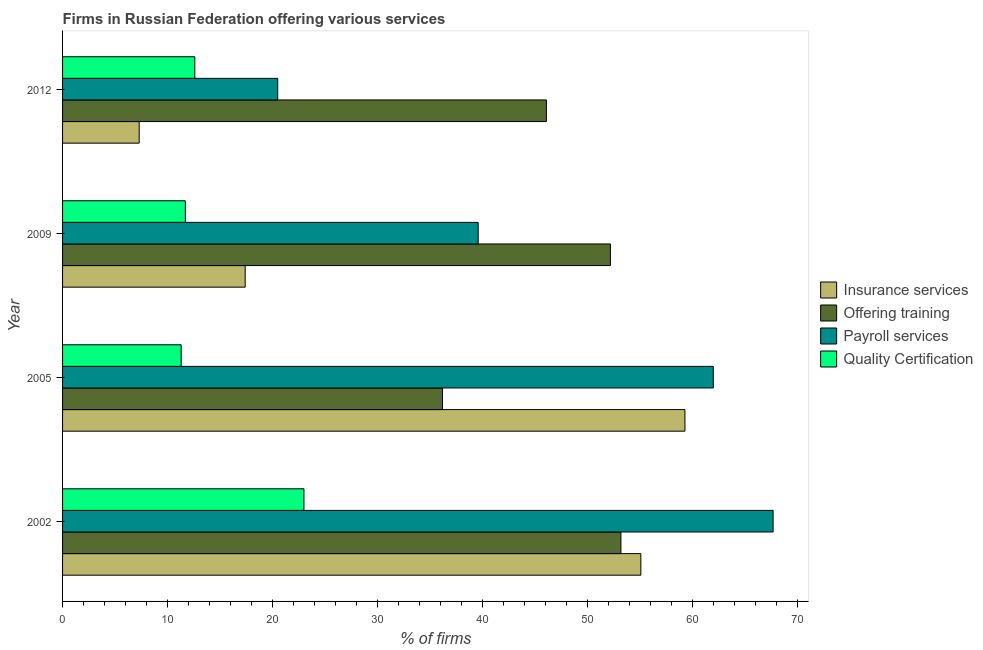How many different coloured bars are there?
Provide a short and direct response. 4. How many groups of bars are there?
Offer a terse response. 4. Are the number of bars per tick equal to the number of legend labels?
Your answer should be compact. Yes. How many bars are there on the 4th tick from the top?
Keep it short and to the point. 4. How many bars are there on the 2nd tick from the bottom?
Provide a short and direct response. 4. In how many cases, is the number of bars for a given year not equal to the number of legend labels?
Offer a terse response. 0. What is the percentage of firms offering insurance services in 2005?
Provide a short and direct response. 59.3. Across all years, what is the maximum percentage of firms offering quality certification?
Provide a succinct answer. 23. Across all years, what is the minimum percentage of firms offering quality certification?
Keep it short and to the point. 11.3. In which year was the percentage of firms offering quality certification maximum?
Provide a succinct answer. 2002. In which year was the percentage of firms offering insurance services minimum?
Provide a succinct answer. 2012. What is the total percentage of firms offering payroll services in the graph?
Your answer should be very brief. 189.8. What is the difference between the percentage of firms offering payroll services in 2002 and the percentage of firms offering training in 2009?
Provide a succinct answer. 15.5. What is the average percentage of firms offering insurance services per year?
Offer a very short reply. 34.77. In the year 2012, what is the difference between the percentage of firms offering payroll services and percentage of firms offering insurance services?
Keep it short and to the point. 13.2. In how many years, is the percentage of firms offering training greater than 26 %?
Your response must be concise. 4. What is the ratio of the percentage of firms offering insurance services in 2002 to that in 2009?
Your answer should be very brief. 3.17. Is the difference between the percentage of firms offering training in 2005 and 2009 greater than the difference between the percentage of firms offering quality certification in 2005 and 2009?
Your response must be concise. No. What is the difference between the highest and the second highest percentage of firms offering quality certification?
Keep it short and to the point. 10.4. What is the difference between the highest and the lowest percentage of firms offering training?
Your answer should be very brief. 17. In how many years, is the percentage of firms offering training greater than the average percentage of firms offering training taken over all years?
Your answer should be very brief. 2. Is the sum of the percentage of firms offering insurance services in 2002 and 2009 greater than the maximum percentage of firms offering quality certification across all years?
Offer a terse response. Yes. What does the 3rd bar from the top in 2002 represents?
Keep it short and to the point. Offering training. What does the 4th bar from the bottom in 2002 represents?
Your answer should be very brief. Quality Certification. Is it the case that in every year, the sum of the percentage of firms offering insurance services and percentage of firms offering training is greater than the percentage of firms offering payroll services?
Keep it short and to the point. Yes. How many years are there in the graph?
Your answer should be very brief. 4. Does the graph contain grids?
Ensure brevity in your answer.  No. Where does the legend appear in the graph?
Make the answer very short. Center right. What is the title of the graph?
Make the answer very short. Firms in Russian Federation offering various services . What is the label or title of the X-axis?
Provide a succinct answer. % of firms. What is the % of firms of Insurance services in 2002?
Provide a succinct answer. 55.1. What is the % of firms in Offering training in 2002?
Give a very brief answer. 53.2. What is the % of firms of Payroll services in 2002?
Your answer should be compact. 67.7. What is the % of firms of Insurance services in 2005?
Keep it short and to the point. 59.3. What is the % of firms in Offering training in 2005?
Provide a succinct answer. 36.2. What is the % of firms of Payroll services in 2005?
Provide a succinct answer. 62. What is the % of firms in Quality Certification in 2005?
Offer a very short reply. 11.3. What is the % of firms in Insurance services in 2009?
Your response must be concise. 17.4. What is the % of firms of Offering training in 2009?
Your response must be concise. 52.2. What is the % of firms in Payroll services in 2009?
Offer a very short reply. 39.6. What is the % of firms in Quality Certification in 2009?
Your response must be concise. 11.7. What is the % of firms in Offering training in 2012?
Your response must be concise. 46.1. What is the % of firms of Payroll services in 2012?
Offer a very short reply. 20.5. What is the % of firms in Quality Certification in 2012?
Your answer should be very brief. 12.6. Across all years, what is the maximum % of firms of Insurance services?
Keep it short and to the point. 59.3. Across all years, what is the maximum % of firms of Offering training?
Your response must be concise. 53.2. Across all years, what is the maximum % of firms of Payroll services?
Ensure brevity in your answer.  67.7. Across all years, what is the maximum % of firms of Quality Certification?
Offer a terse response. 23. Across all years, what is the minimum % of firms of Insurance services?
Make the answer very short. 7.3. Across all years, what is the minimum % of firms of Offering training?
Offer a terse response. 36.2. What is the total % of firms of Insurance services in the graph?
Your answer should be compact. 139.1. What is the total % of firms of Offering training in the graph?
Keep it short and to the point. 187.7. What is the total % of firms of Payroll services in the graph?
Keep it short and to the point. 189.8. What is the total % of firms in Quality Certification in the graph?
Keep it short and to the point. 58.6. What is the difference between the % of firms in Payroll services in 2002 and that in 2005?
Provide a short and direct response. 5.7. What is the difference between the % of firms of Insurance services in 2002 and that in 2009?
Give a very brief answer. 37.7. What is the difference between the % of firms of Payroll services in 2002 and that in 2009?
Keep it short and to the point. 28.1. What is the difference between the % of firms in Insurance services in 2002 and that in 2012?
Your answer should be compact. 47.8. What is the difference between the % of firms of Payroll services in 2002 and that in 2012?
Your answer should be compact. 47.2. What is the difference between the % of firms in Insurance services in 2005 and that in 2009?
Keep it short and to the point. 41.9. What is the difference between the % of firms of Payroll services in 2005 and that in 2009?
Offer a terse response. 22.4. What is the difference between the % of firms of Quality Certification in 2005 and that in 2009?
Your response must be concise. -0.4. What is the difference between the % of firms in Insurance services in 2005 and that in 2012?
Give a very brief answer. 52. What is the difference between the % of firms in Payroll services in 2005 and that in 2012?
Provide a succinct answer. 41.5. What is the difference between the % of firms of Quality Certification in 2005 and that in 2012?
Give a very brief answer. -1.3. What is the difference between the % of firms in Payroll services in 2009 and that in 2012?
Keep it short and to the point. 19.1. What is the difference between the % of firms in Insurance services in 2002 and the % of firms in Offering training in 2005?
Make the answer very short. 18.9. What is the difference between the % of firms of Insurance services in 2002 and the % of firms of Payroll services in 2005?
Provide a succinct answer. -6.9. What is the difference between the % of firms in Insurance services in 2002 and the % of firms in Quality Certification in 2005?
Make the answer very short. 43.8. What is the difference between the % of firms of Offering training in 2002 and the % of firms of Payroll services in 2005?
Provide a succinct answer. -8.8. What is the difference between the % of firms of Offering training in 2002 and the % of firms of Quality Certification in 2005?
Provide a short and direct response. 41.9. What is the difference between the % of firms in Payroll services in 2002 and the % of firms in Quality Certification in 2005?
Make the answer very short. 56.4. What is the difference between the % of firms in Insurance services in 2002 and the % of firms in Payroll services in 2009?
Provide a short and direct response. 15.5. What is the difference between the % of firms in Insurance services in 2002 and the % of firms in Quality Certification in 2009?
Your answer should be compact. 43.4. What is the difference between the % of firms in Offering training in 2002 and the % of firms in Payroll services in 2009?
Your response must be concise. 13.6. What is the difference between the % of firms of Offering training in 2002 and the % of firms of Quality Certification in 2009?
Offer a very short reply. 41.5. What is the difference between the % of firms in Payroll services in 2002 and the % of firms in Quality Certification in 2009?
Provide a succinct answer. 56. What is the difference between the % of firms in Insurance services in 2002 and the % of firms in Offering training in 2012?
Ensure brevity in your answer.  9. What is the difference between the % of firms in Insurance services in 2002 and the % of firms in Payroll services in 2012?
Make the answer very short. 34.6. What is the difference between the % of firms in Insurance services in 2002 and the % of firms in Quality Certification in 2012?
Provide a succinct answer. 42.5. What is the difference between the % of firms in Offering training in 2002 and the % of firms in Payroll services in 2012?
Offer a very short reply. 32.7. What is the difference between the % of firms of Offering training in 2002 and the % of firms of Quality Certification in 2012?
Make the answer very short. 40.6. What is the difference between the % of firms of Payroll services in 2002 and the % of firms of Quality Certification in 2012?
Give a very brief answer. 55.1. What is the difference between the % of firms in Insurance services in 2005 and the % of firms in Offering training in 2009?
Provide a short and direct response. 7.1. What is the difference between the % of firms of Insurance services in 2005 and the % of firms of Payroll services in 2009?
Your answer should be very brief. 19.7. What is the difference between the % of firms of Insurance services in 2005 and the % of firms of Quality Certification in 2009?
Give a very brief answer. 47.6. What is the difference between the % of firms of Offering training in 2005 and the % of firms of Payroll services in 2009?
Your answer should be very brief. -3.4. What is the difference between the % of firms of Payroll services in 2005 and the % of firms of Quality Certification in 2009?
Provide a short and direct response. 50.3. What is the difference between the % of firms in Insurance services in 2005 and the % of firms in Offering training in 2012?
Your answer should be compact. 13.2. What is the difference between the % of firms in Insurance services in 2005 and the % of firms in Payroll services in 2012?
Offer a terse response. 38.8. What is the difference between the % of firms of Insurance services in 2005 and the % of firms of Quality Certification in 2012?
Offer a terse response. 46.7. What is the difference between the % of firms of Offering training in 2005 and the % of firms of Quality Certification in 2012?
Your answer should be very brief. 23.6. What is the difference between the % of firms in Payroll services in 2005 and the % of firms in Quality Certification in 2012?
Offer a very short reply. 49.4. What is the difference between the % of firms of Insurance services in 2009 and the % of firms of Offering training in 2012?
Provide a short and direct response. -28.7. What is the difference between the % of firms in Insurance services in 2009 and the % of firms in Payroll services in 2012?
Offer a terse response. -3.1. What is the difference between the % of firms in Insurance services in 2009 and the % of firms in Quality Certification in 2012?
Keep it short and to the point. 4.8. What is the difference between the % of firms in Offering training in 2009 and the % of firms in Payroll services in 2012?
Your answer should be compact. 31.7. What is the difference between the % of firms of Offering training in 2009 and the % of firms of Quality Certification in 2012?
Provide a succinct answer. 39.6. What is the average % of firms of Insurance services per year?
Keep it short and to the point. 34.77. What is the average % of firms of Offering training per year?
Your answer should be compact. 46.92. What is the average % of firms in Payroll services per year?
Provide a short and direct response. 47.45. What is the average % of firms of Quality Certification per year?
Make the answer very short. 14.65. In the year 2002, what is the difference between the % of firms of Insurance services and % of firms of Payroll services?
Your answer should be compact. -12.6. In the year 2002, what is the difference between the % of firms of Insurance services and % of firms of Quality Certification?
Make the answer very short. 32.1. In the year 2002, what is the difference between the % of firms in Offering training and % of firms in Payroll services?
Offer a very short reply. -14.5. In the year 2002, what is the difference between the % of firms of Offering training and % of firms of Quality Certification?
Offer a terse response. 30.2. In the year 2002, what is the difference between the % of firms in Payroll services and % of firms in Quality Certification?
Give a very brief answer. 44.7. In the year 2005, what is the difference between the % of firms of Insurance services and % of firms of Offering training?
Provide a succinct answer. 23.1. In the year 2005, what is the difference between the % of firms of Insurance services and % of firms of Quality Certification?
Provide a short and direct response. 48. In the year 2005, what is the difference between the % of firms of Offering training and % of firms of Payroll services?
Ensure brevity in your answer.  -25.8. In the year 2005, what is the difference between the % of firms of Offering training and % of firms of Quality Certification?
Give a very brief answer. 24.9. In the year 2005, what is the difference between the % of firms of Payroll services and % of firms of Quality Certification?
Your response must be concise. 50.7. In the year 2009, what is the difference between the % of firms in Insurance services and % of firms in Offering training?
Offer a terse response. -34.8. In the year 2009, what is the difference between the % of firms of Insurance services and % of firms of Payroll services?
Offer a very short reply. -22.2. In the year 2009, what is the difference between the % of firms of Offering training and % of firms of Payroll services?
Your answer should be very brief. 12.6. In the year 2009, what is the difference between the % of firms of Offering training and % of firms of Quality Certification?
Your answer should be compact. 40.5. In the year 2009, what is the difference between the % of firms of Payroll services and % of firms of Quality Certification?
Offer a terse response. 27.9. In the year 2012, what is the difference between the % of firms of Insurance services and % of firms of Offering training?
Offer a terse response. -38.8. In the year 2012, what is the difference between the % of firms of Insurance services and % of firms of Quality Certification?
Keep it short and to the point. -5.3. In the year 2012, what is the difference between the % of firms in Offering training and % of firms in Payroll services?
Keep it short and to the point. 25.6. In the year 2012, what is the difference between the % of firms in Offering training and % of firms in Quality Certification?
Provide a succinct answer. 33.5. What is the ratio of the % of firms in Insurance services in 2002 to that in 2005?
Make the answer very short. 0.93. What is the ratio of the % of firms in Offering training in 2002 to that in 2005?
Your answer should be very brief. 1.47. What is the ratio of the % of firms in Payroll services in 2002 to that in 2005?
Your response must be concise. 1.09. What is the ratio of the % of firms of Quality Certification in 2002 to that in 2005?
Your answer should be very brief. 2.04. What is the ratio of the % of firms in Insurance services in 2002 to that in 2009?
Provide a short and direct response. 3.17. What is the ratio of the % of firms of Offering training in 2002 to that in 2009?
Ensure brevity in your answer.  1.02. What is the ratio of the % of firms of Payroll services in 2002 to that in 2009?
Offer a very short reply. 1.71. What is the ratio of the % of firms in Quality Certification in 2002 to that in 2009?
Provide a short and direct response. 1.97. What is the ratio of the % of firms in Insurance services in 2002 to that in 2012?
Give a very brief answer. 7.55. What is the ratio of the % of firms of Offering training in 2002 to that in 2012?
Your response must be concise. 1.15. What is the ratio of the % of firms in Payroll services in 2002 to that in 2012?
Give a very brief answer. 3.3. What is the ratio of the % of firms of Quality Certification in 2002 to that in 2012?
Offer a very short reply. 1.83. What is the ratio of the % of firms of Insurance services in 2005 to that in 2009?
Give a very brief answer. 3.41. What is the ratio of the % of firms in Offering training in 2005 to that in 2009?
Ensure brevity in your answer.  0.69. What is the ratio of the % of firms of Payroll services in 2005 to that in 2009?
Your answer should be compact. 1.57. What is the ratio of the % of firms of Quality Certification in 2005 to that in 2009?
Your answer should be very brief. 0.97. What is the ratio of the % of firms of Insurance services in 2005 to that in 2012?
Your answer should be compact. 8.12. What is the ratio of the % of firms in Offering training in 2005 to that in 2012?
Keep it short and to the point. 0.79. What is the ratio of the % of firms in Payroll services in 2005 to that in 2012?
Give a very brief answer. 3.02. What is the ratio of the % of firms in Quality Certification in 2005 to that in 2012?
Provide a succinct answer. 0.9. What is the ratio of the % of firms in Insurance services in 2009 to that in 2012?
Offer a terse response. 2.38. What is the ratio of the % of firms in Offering training in 2009 to that in 2012?
Your response must be concise. 1.13. What is the ratio of the % of firms in Payroll services in 2009 to that in 2012?
Make the answer very short. 1.93. What is the ratio of the % of firms in Quality Certification in 2009 to that in 2012?
Provide a short and direct response. 0.93. What is the difference between the highest and the second highest % of firms in Insurance services?
Your answer should be very brief. 4.2. What is the difference between the highest and the second highest % of firms of Offering training?
Ensure brevity in your answer.  1. What is the difference between the highest and the second highest % of firms of Payroll services?
Your answer should be compact. 5.7. What is the difference between the highest and the lowest % of firms of Payroll services?
Your answer should be compact. 47.2. 